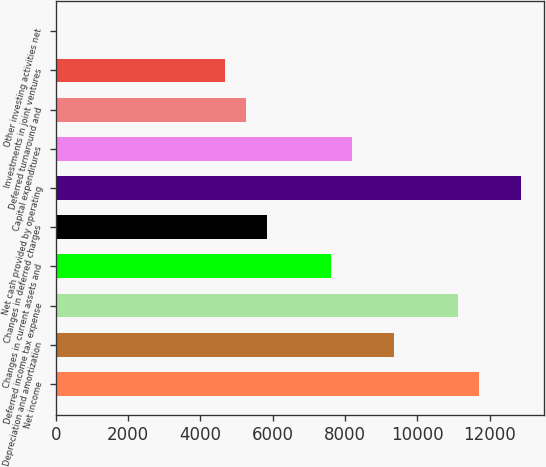Convert chart. <chart><loc_0><loc_0><loc_500><loc_500><bar_chart><fcel>Net income<fcel>Depreciation and amortization<fcel>Deferred income tax expense<fcel>Changes in current assets and<fcel>Changes in deferred charges<fcel>Net cash provided by operating<fcel>Capital expenditures<fcel>Deferred turnaround and<fcel>Investments in joint ventures<fcel>Other investing activities net<nl><fcel>11698<fcel>9358.8<fcel>11113.2<fcel>7604.4<fcel>5850<fcel>12867.6<fcel>8189.2<fcel>5265.2<fcel>4680.4<fcel>2<nl></chart> 